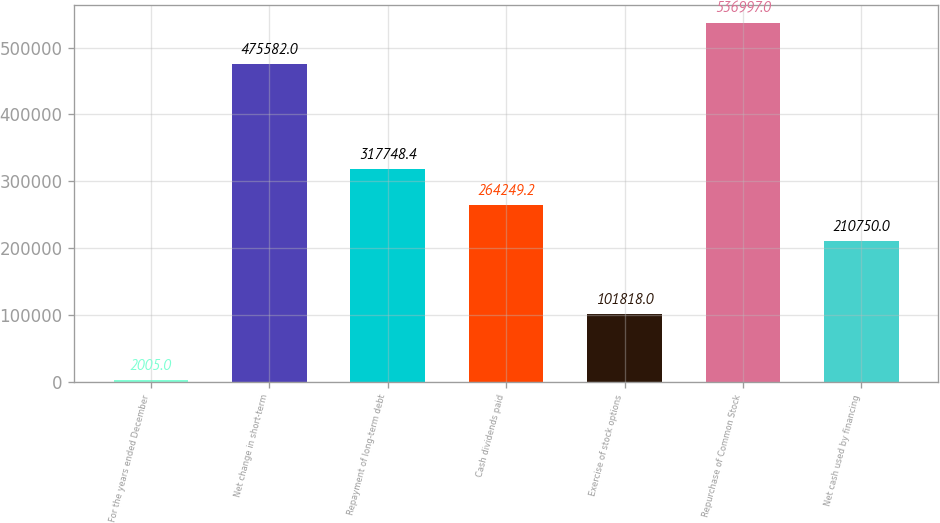Convert chart. <chart><loc_0><loc_0><loc_500><loc_500><bar_chart><fcel>For the years ended December<fcel>Net change in short-term<fcel>Repayment of long-term debt<fcel>Cash dividends paid<fcel>Exercise of stock options<fcel>Repurchase of Common Stock<fcel>Net cash used by financing<nl><fcel>2005<fcel>475582<fcel>317748<fcel>264249<fcel>101818<fcel>536997<fcel>210750<nl></chart> 